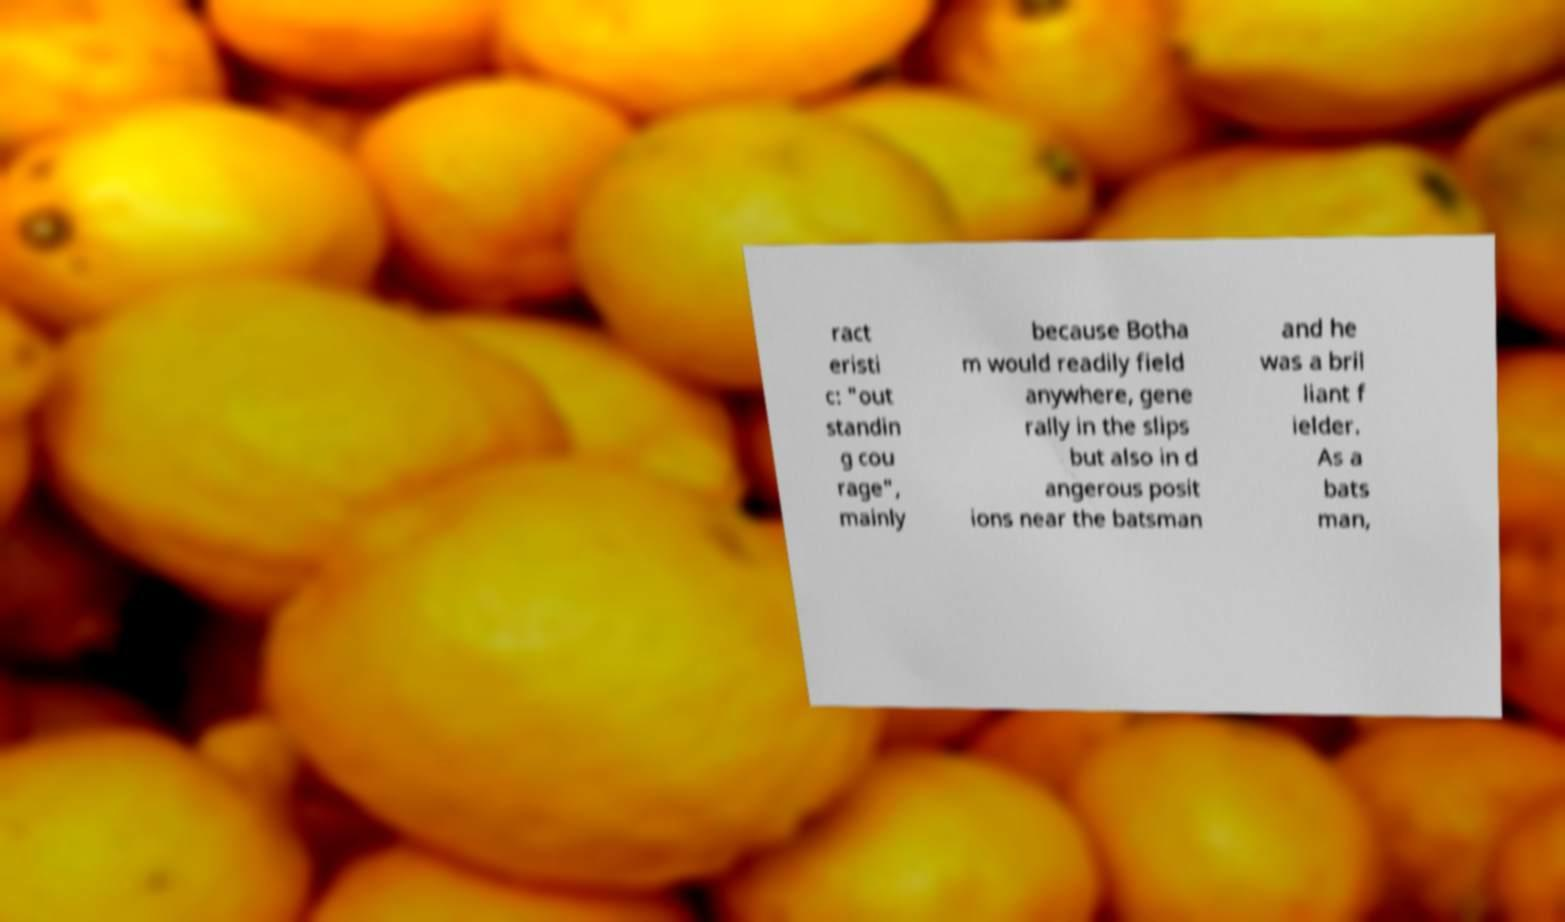Can you read and provide the text displayed in the image?This photo seems to have some interesting text. Can you extract and type it out for me? ract eristi c: "out standin g cou rage", mainly because Botha m would readily field anywhere, gene rally in the slips but also in d angerous posit ions near the batsman and he was a bril liant f ielder. As a bats man, 